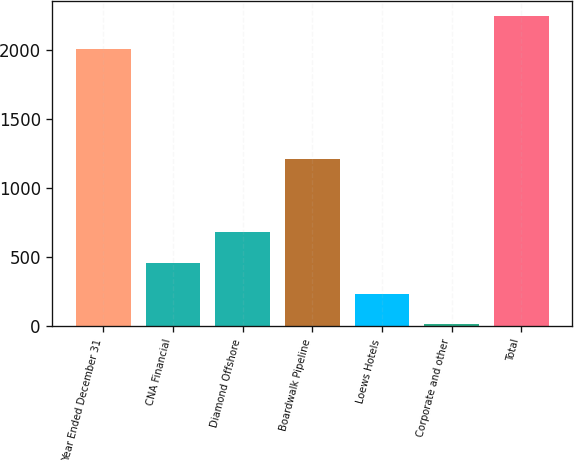<chart> <loc_0><loc_0><loc_500><loc_500><bar_chart><fcel>Year Ended December 31<fcel>CNA Financial<fcel>Diamond Offshore<fcel>Boardwalk Pipeline<fcel>Loews Hotels<fcel>Corporate and other<fcel>Total<nl><fcel>2007<fcel>460.6<fcel>683.9<fcel>1214<fcel>237.3<fcel>14<fcel>2247<nl></chart> 